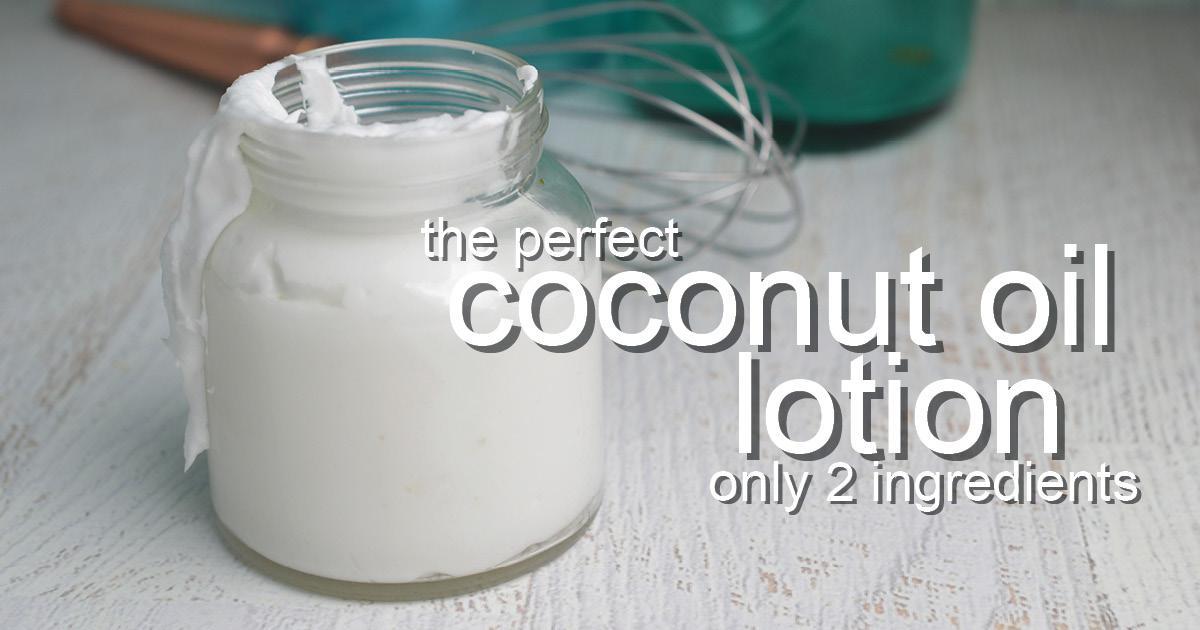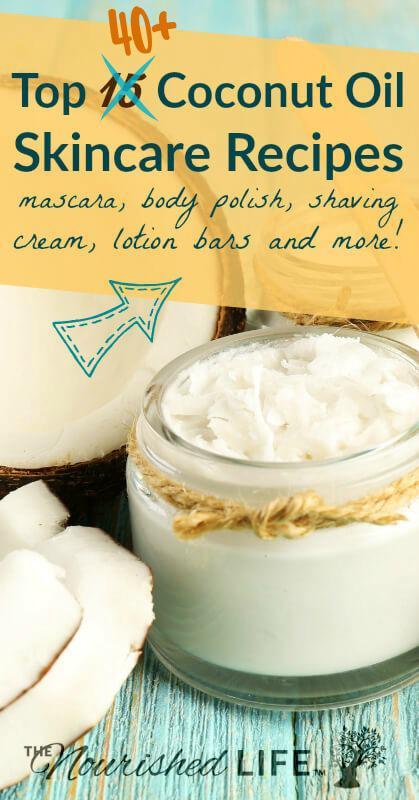The first image is the image on the left, the second image is the image on the right. Considering the images on both sides, is "None of the creams are green." valid? Answer yes or no. Yes. The first image is the image on the left, the second image is the image on the right. Examine the images to the left and right. Is the description "There are no spoons or spatulas in any of the images." accurate? Answer yes or no. Yes. 